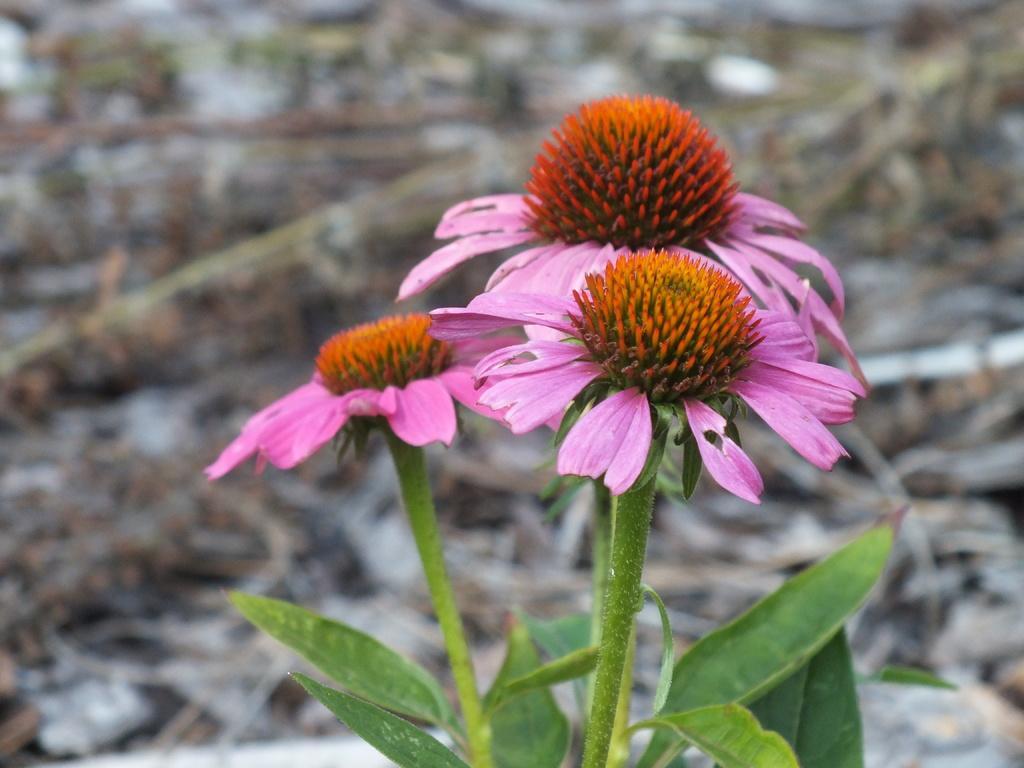How would you summarize this image in a sentence or two? In the foreground of the picture there are flowers, leaves and stems. The background is blurred. 